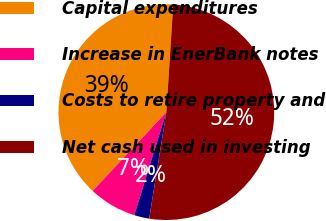Convert chart to OTSL. <chart><loc_0><loc_0><loc_500><loc_500><pie_chart><fcel>Capital expenditures<fcel>Increase in EnerBank notes<fcel>Costs to retire property and<fcel>Net cash used in investing<nl><fcel>39.05%<fcel>7.18%<fcel>2.25%<fcel>51.53%<nl></chart> 